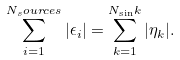Convert formula to latex. <formula><loc_0><loc_0><loc_500><loc_500>\sum _ { i = 1 } ^ { N _ { s } o u r c e s } | \epsilon _ { i } | = \sum _ { k = 1 } ^ { N _ { \sin } k } | \eta _ { k } | .</formula> 